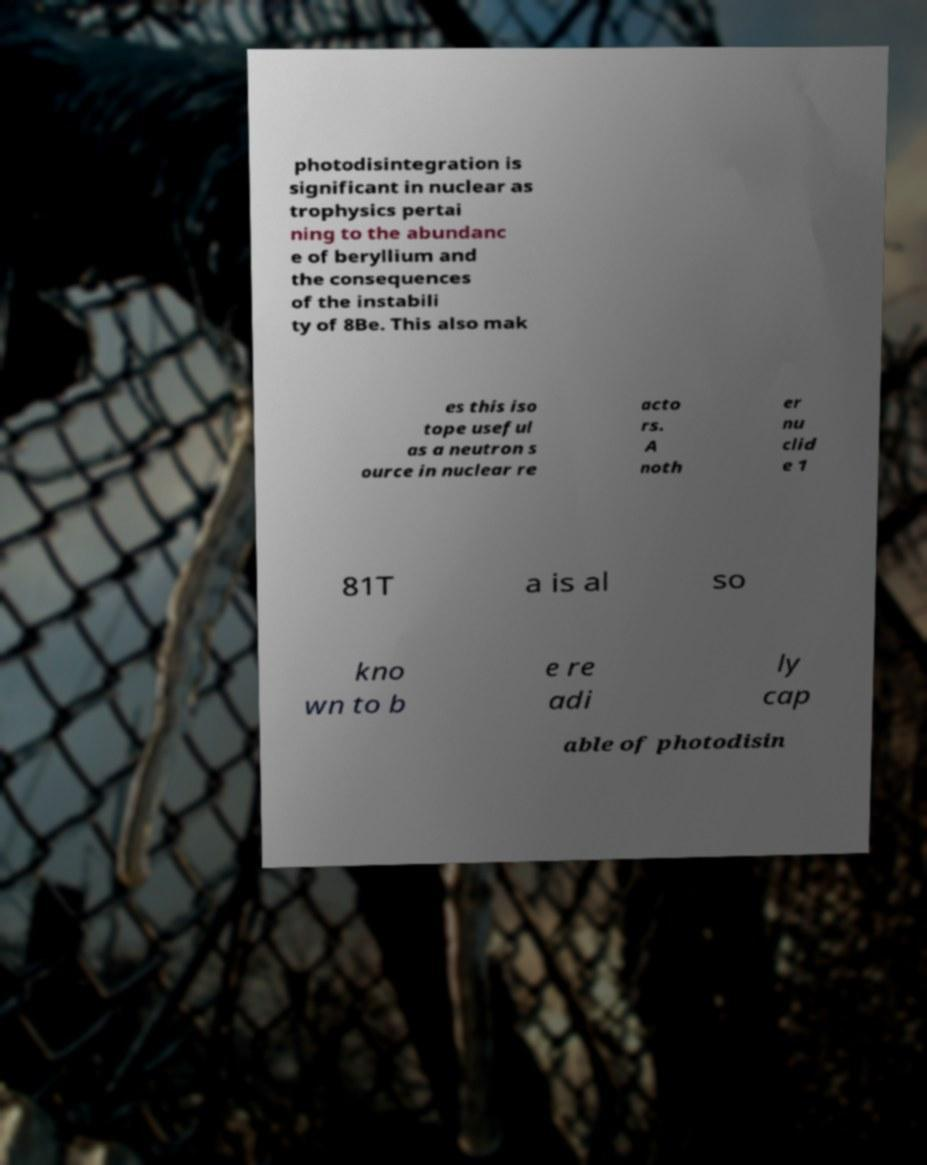Can you read and provide the text displayed in the image?This photo seems to have some interesting text. Can you extract and type it out for me? photodisintegration is significant in nuclear as trophysics pertai ning to the abundanc e of beryllium and the consequences of the instabili ty of 8Be. This also mak es this iso tope useful as a neutron s ource in nuclear re acto rs. A noth er nu clid e 1 81T a is al so kno wn to b e re adi ly cap able of photodisin 